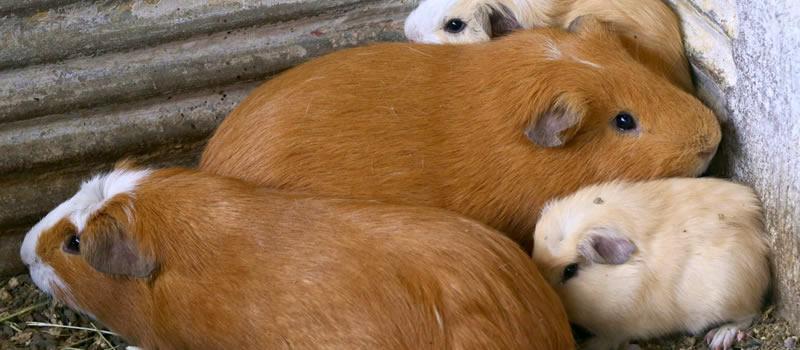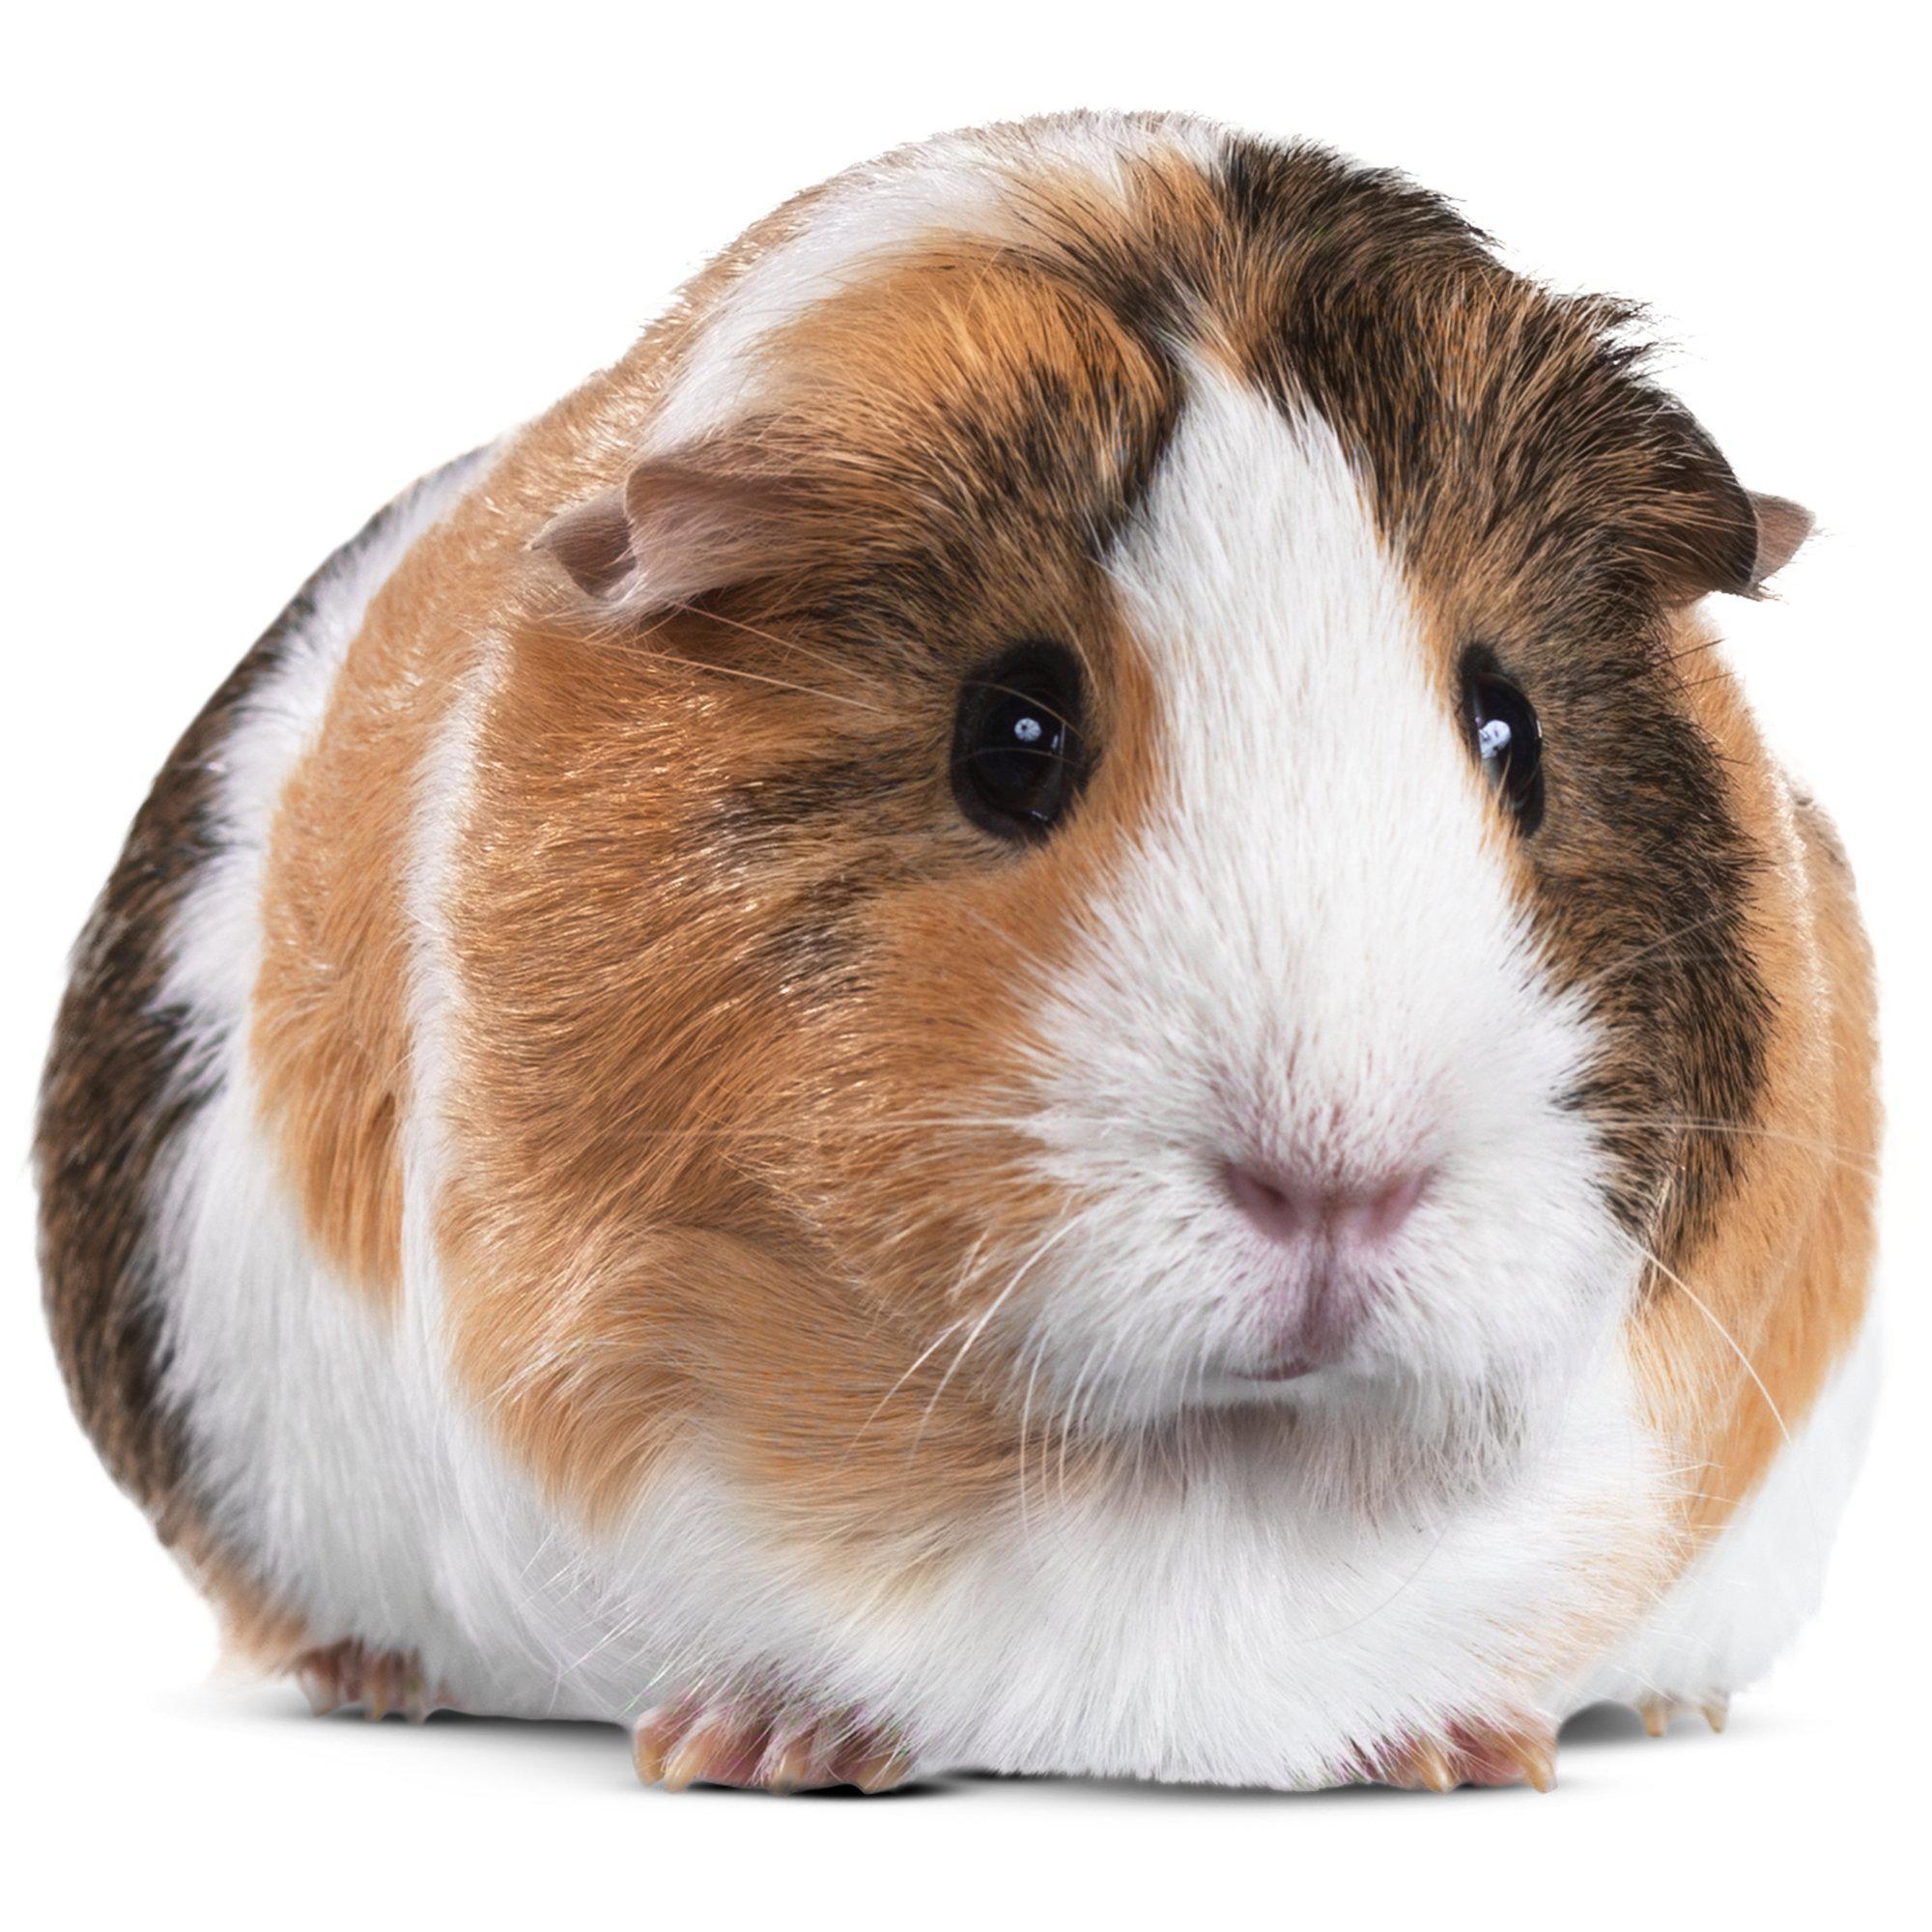The first image is the image on the left, the second image is the image on the right. Given the left and right images, does the statement "There are two guinea pigs in one image." hold true? Answer yes or no. No. The first image is the image on the left, the second image is the image on the right. Given the left and right images, does the statement "There are at least four guinea pigs in total." hold true? Answer yes or no. Yes. 